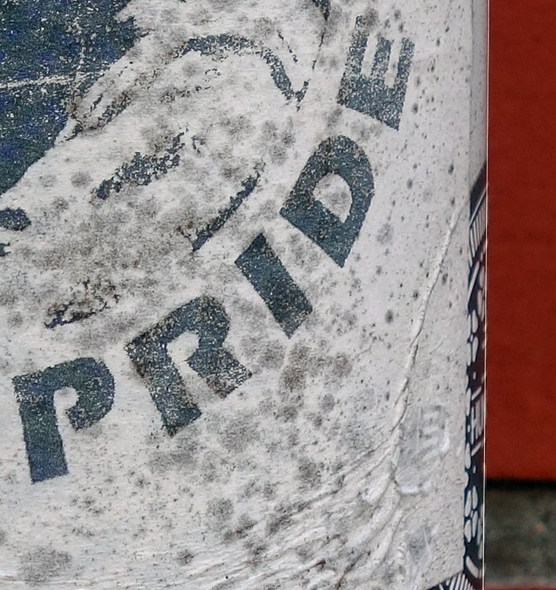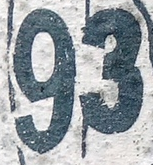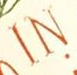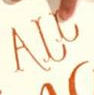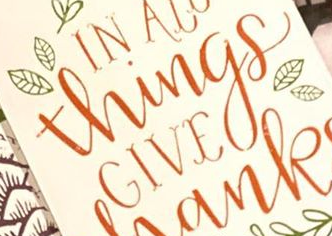What text appears in these images from left to right, separated by a semicolon? PRIDE; 93; IN; ALL; Things 